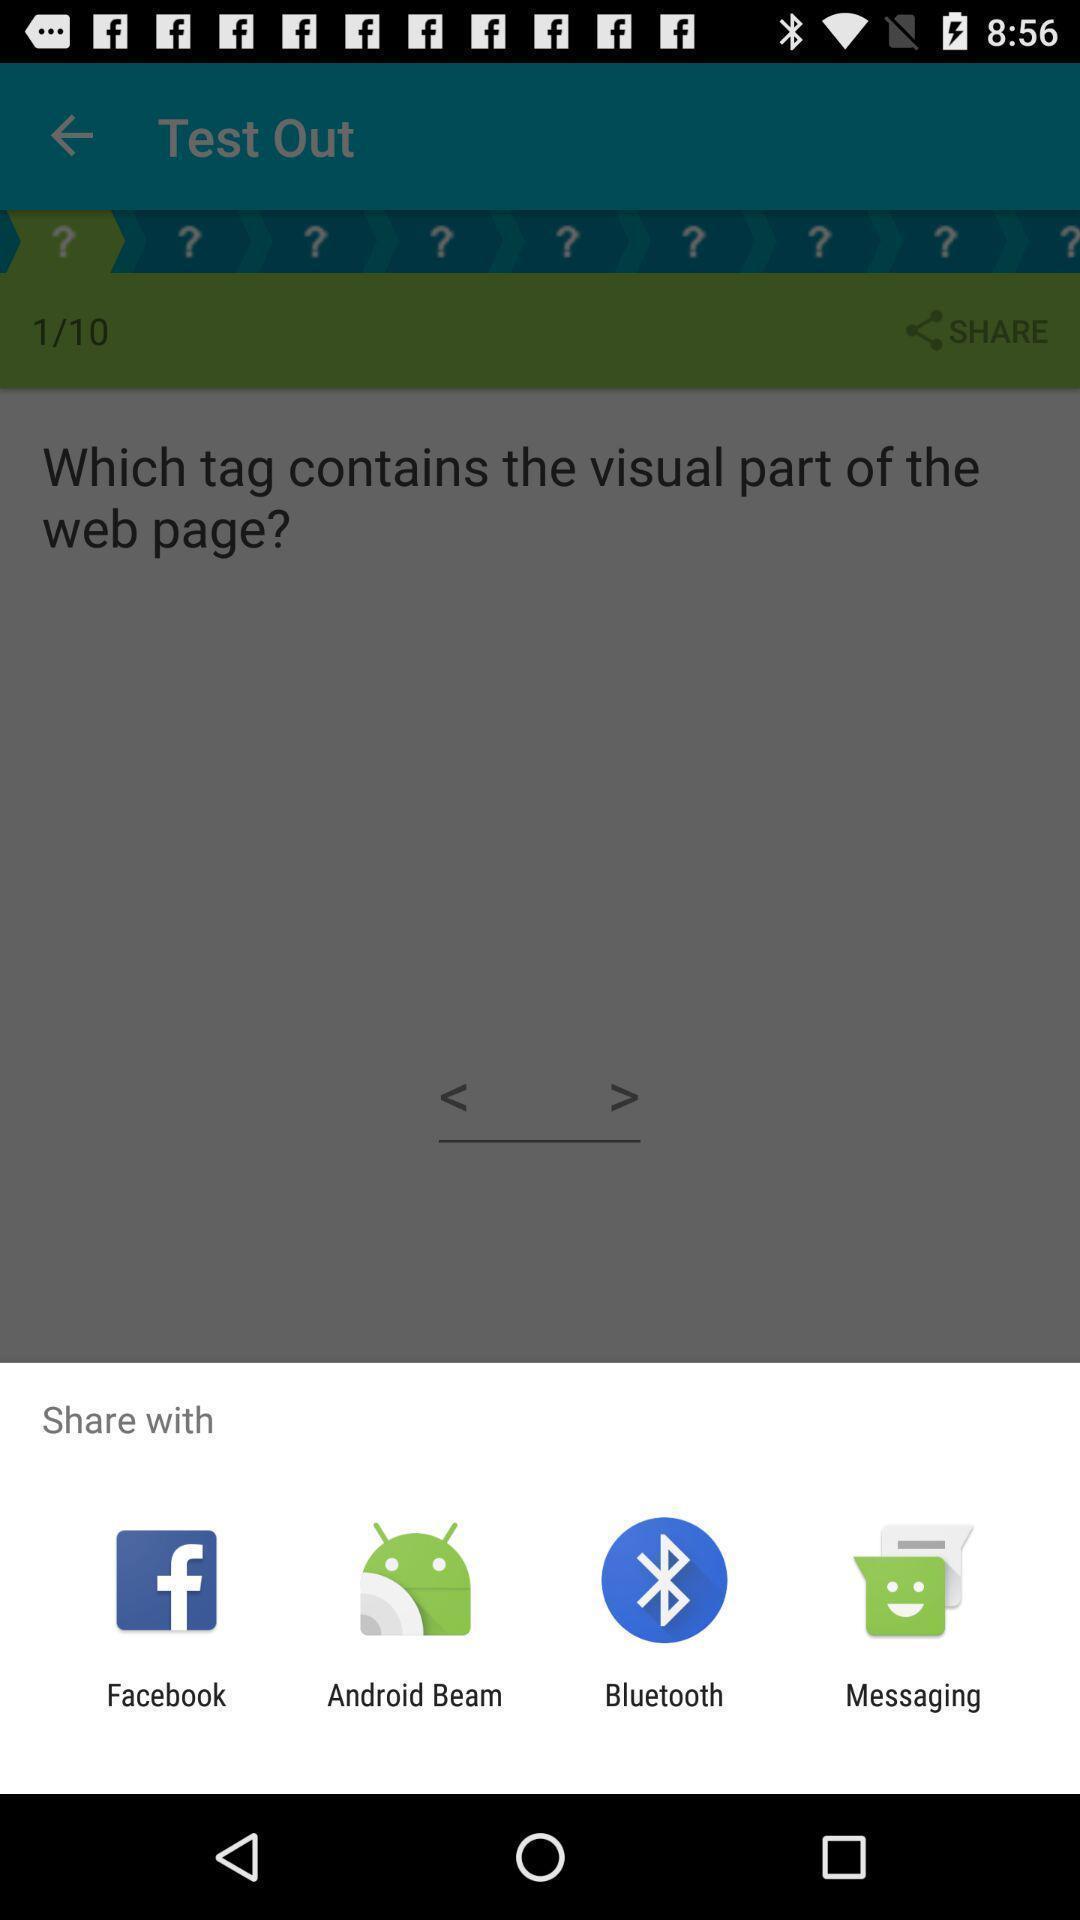What can you discern from this picture? Push up message for sharing data via social network. 